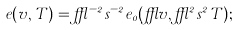<formula> <loc_0><loc_0><loc_500><loc_500>e ( v , T ) = \epsilon ^ { - 2 } s ^ { - 2 } e _ { 0 } ( \epsilon v , \epsilon ^ { 2 } s ^ { 2 } T ) ;</formula> 